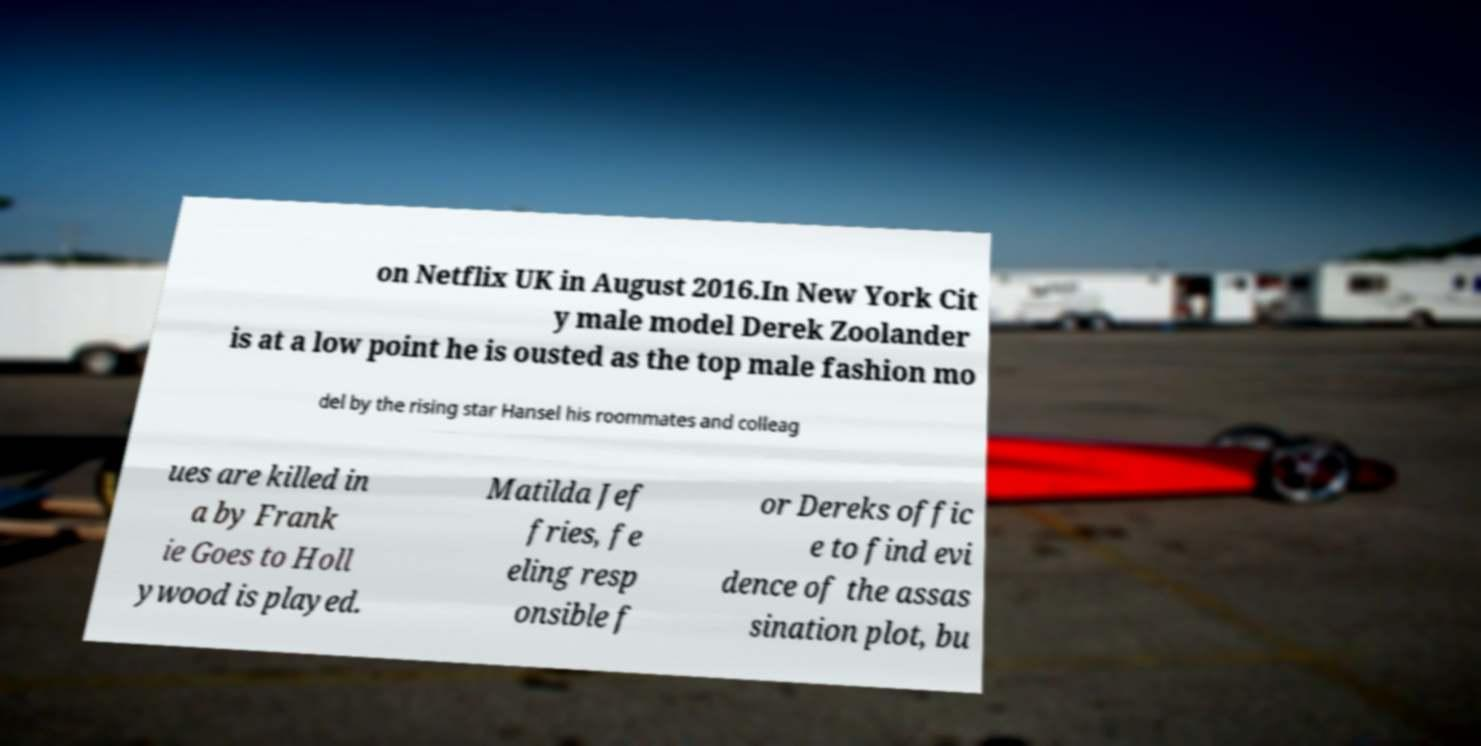What messages or text are displayed in this image? I need them in a readable, typed format. on Netflix UK in August 2016.In New York Cit y male model Derek Zoolander is at a low point he is ousted as the top male fashion mo del by the rising star Hansel his roommates and colleag ues are killed in a by Frank ie Goes to Holl ywood is played. Matilda Jef fries, fe eling resp onsible f or Dereks offic e to find evi dence of the assas sination plot, bu 